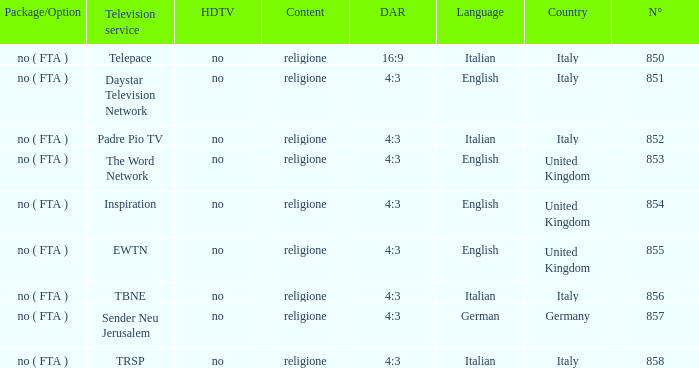What television service is in italy and is in english? Daystar Television Network. 